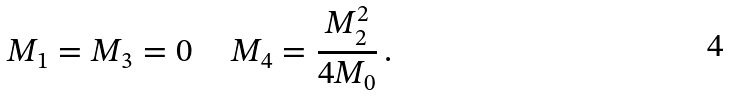Convert formula to latex. <formula><loc_0><loc_0><loc_500><loc_500>M _ { 1 } = M _ { 3 } = 0 \, \quad M _ { 4 } = \frac { M _ { 2 } ^ { 2 } } { 4 M _ { 0 } } \, .</formula> 